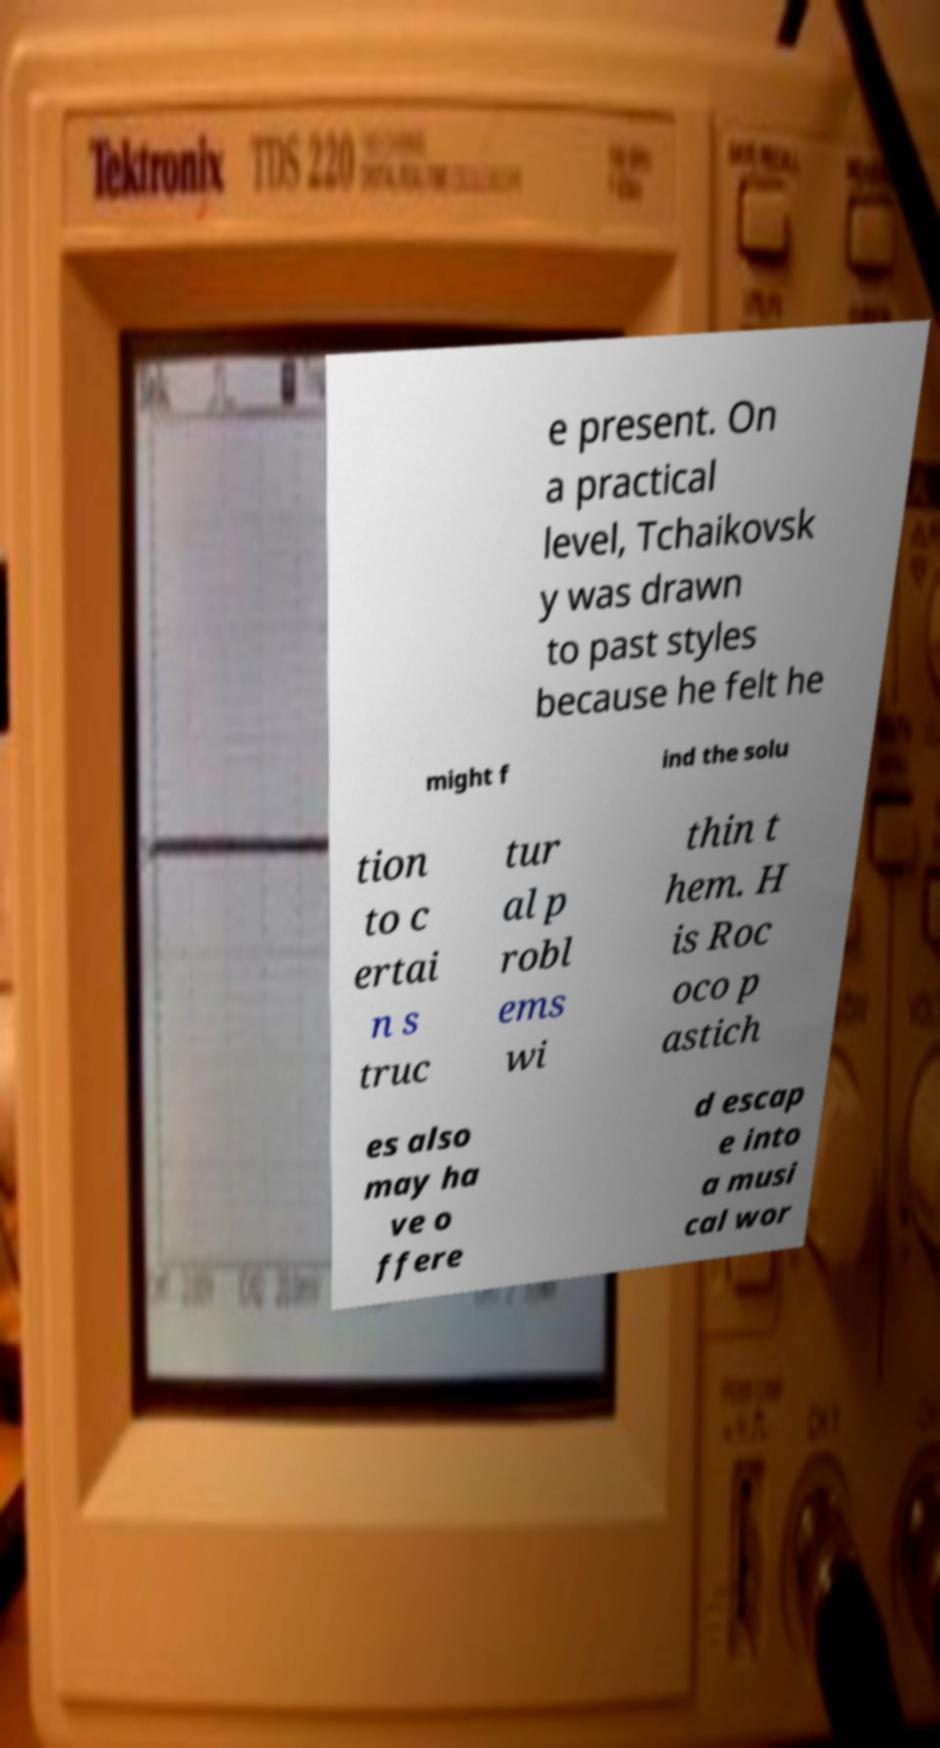Could you assist in decoding the text presented in this image and type it out clearly? e present. On a practical level, Tchaikovsk y was drawn to past styles because he felt he might f ind the solu tion to c ertai n s truc tur al p robl ems wi thin t hem. H is Roc oco p astich es also may ha ve o ffere d escap e into a musi cal wor 